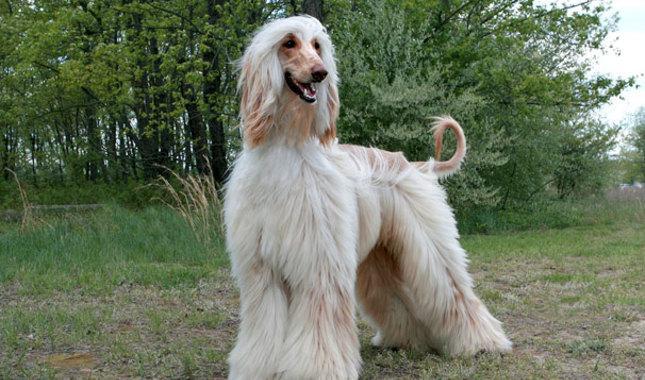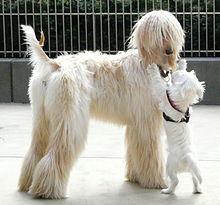The first image is the image on the left, the second image is the image on the right. Considering the images on both sides, is "Four dog feet are visible in the image on the left." valid? Answer yes or no. Yes. 